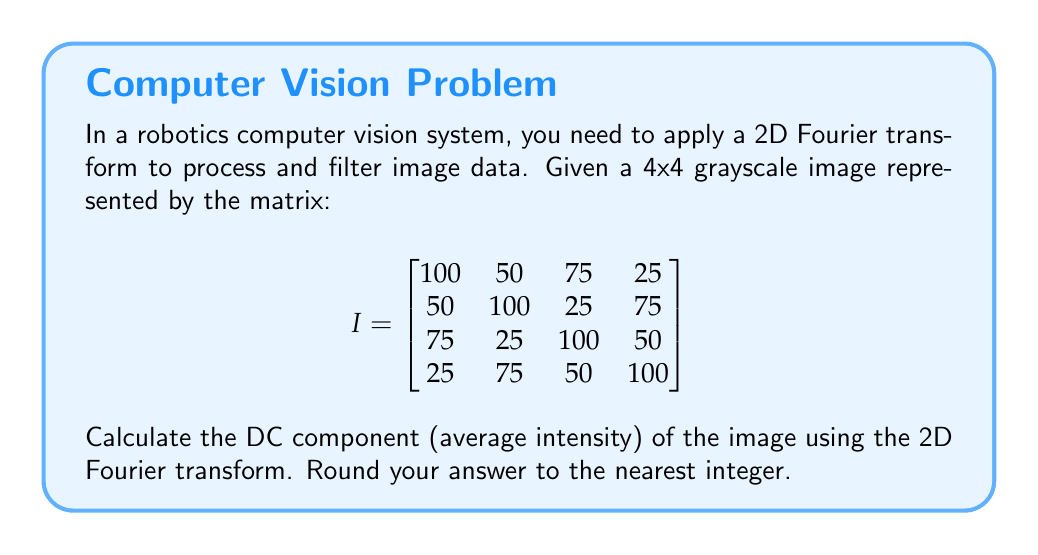Could you help me with this problem? To solve this problem, we'll follow these steps:

1) The 2D Fourier transform of an NxN image is given by:

   $$F(u,v) = \frac{1}{N^2} \sum_{x=0}^{N-1} \sum_{y=0}^{N-1} f(x,y) e^{-j2\pi(\frac{ux}{N} + \frac{vy}{N})}$$

   where $f(x,y)$ is the pixel value at position $(x,y)$, and $(u,v)$ are the frequency coordinates.

2) The DC component is the average intensity of the image, which corresponds to $F(0,0)$ in the frequency domain. When $u=v=0$, the exponential term becomes 1:

   $$F(0,0) = \frac{1}{N^2} \sum_{x=0}^{N-1} \sum_{y=0}^{N-1} f(x,y)$$

3) This simplifies to the sum of all pixel values divided by the total number of pixels:

   $$F(0,0) = \frac{1}{N^2} \sum_{all pixels} f(x,y)$$

4) For our 4x4 image:
   
   Sum of all pixels = 100 + 50 + 75 + 25 + 50 + 100 + 25 + 75 + 75 + 25 + 100 + 50 + 25 + 75 + 50 + 100 = 1000

   Total number of pixels = 4 * 4 = 16

5) Therefore:

   $$F(0,0) = \frac{1000}{16} = 62.5$$

6) Rounding to the nearest integer gives us 63.
Answer: 63 